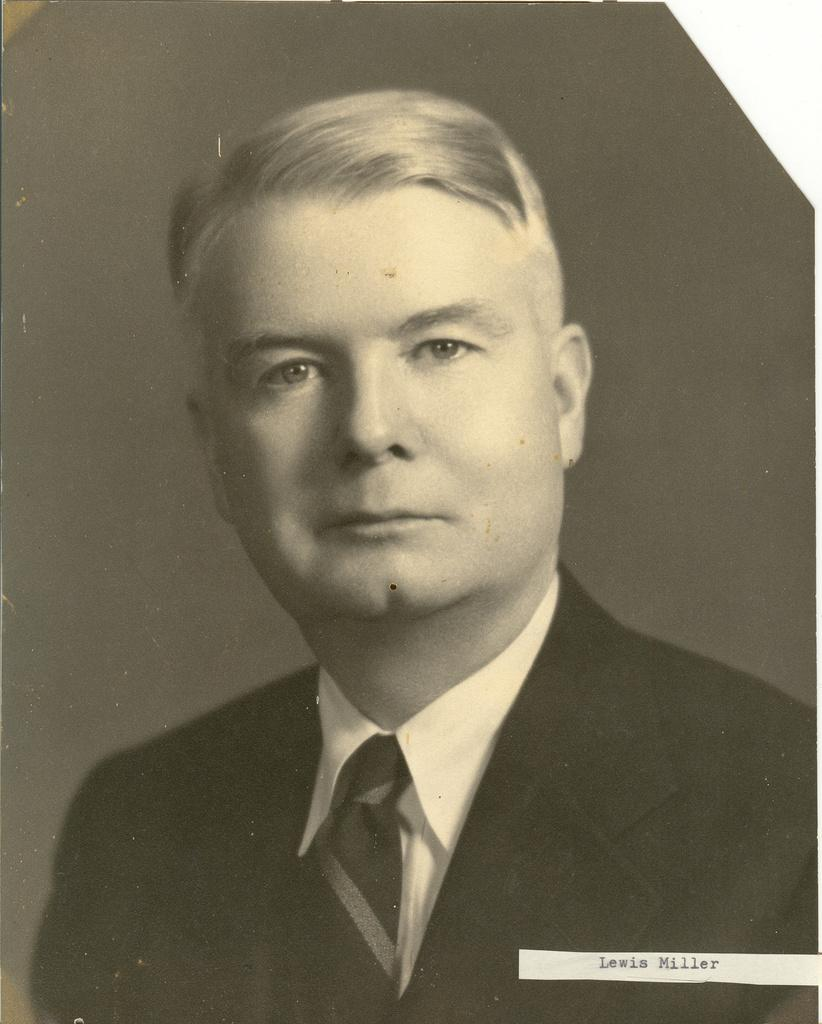What is the color scheme of the image? The image is black and white. Who is present in the image? There is a man in the image. What is the man wearing? The man is wearing a suit and a tie. Is there any text or marking at the bottom of the image? Yes, there is a watermark at the bottom of the image. Can you hear the man laughing in the image? The image is a still photograph, so there is no sound or laughter present. Is there a carriage visible in the image? There is no carriage present in the image; it only features a man wearing a suit and a tie. 